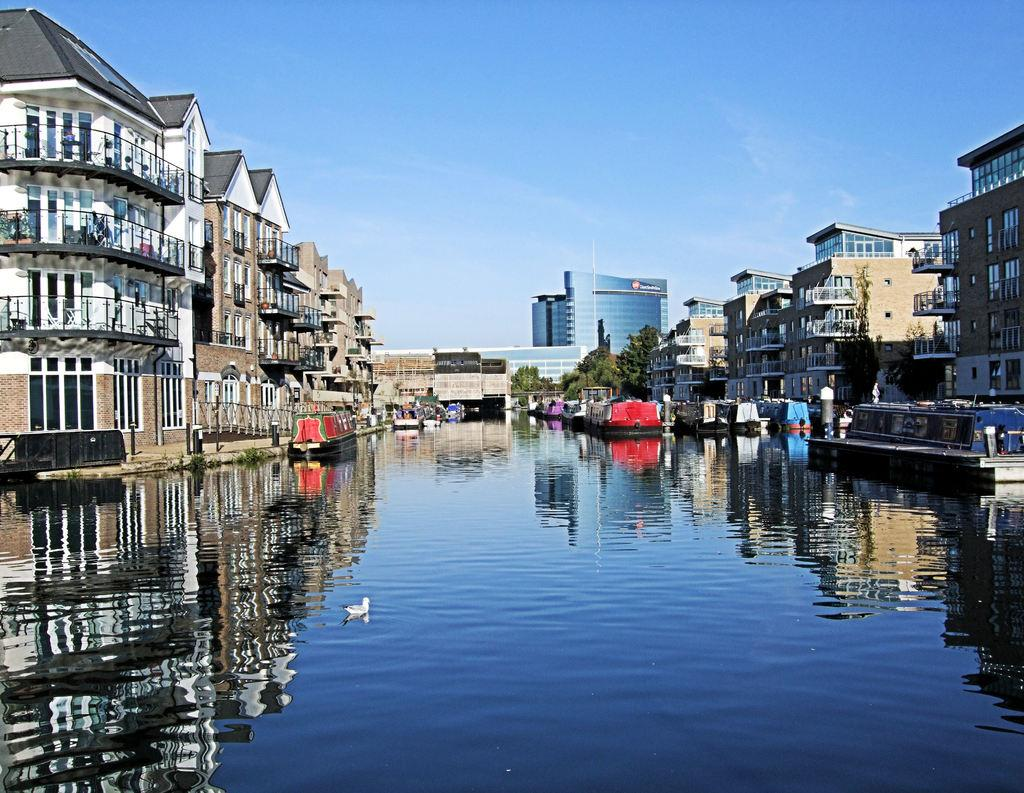What type of location is shown in the image? The image depicts a city. What can be seen in the water in the image? There is a duck in the water. What else is present on the water in the image? There are boats on the water. What structures are visible in the image? There are buildings in the image. What type of vegetation can be seen in the image? There are trees in the image. What is visible in the background of the image? The sky is visible in the background. Where is the farmer working in the image? There is no farmer present in the image. What type of clothing is the top folding in the image? There is no clothing or folding present in the image. 